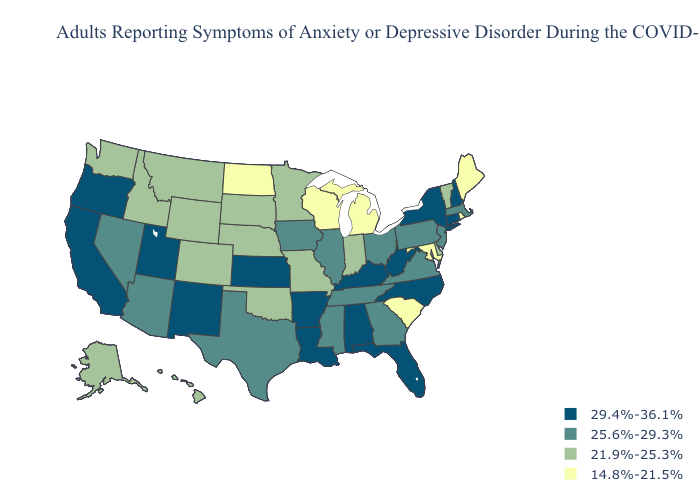What is the value of Indiana?
Answer briefly. 21.9%-25.3%. Name the states that have a value in the range 25.6%-29.3%?
Quick response, please. Arizona, Georgia, Illinois, Iowa, Massachusetts, Mississippi, Nevada, New Jersey, Ohio, Pennsylvania, Tennessee, Texas, Virginia. Name the states that have a value in the range 25.6%-29.3%?
Give a very brief answer. Arizona, Georgia, Illinois, Iowa, Massachusetts, Mississippi, Nevada, New Jersey, Ohio, Pennsylvania, Tennessee, Texas, Virginia. Name the states that have a value in the range 25.6%-29.3%?
Quick response, please. Arizona, Georgia, Illinois, Iowa, Massachusetts, Mississippi, Nevada, New Jersey, Ohio, Pennsylvania, Tennessee, Texas, Virginia. Which states have the lowest value in the West?
Write a very short answer. Alaska, Colorado, Hawaii, Idaho, Montana, Washington, Wyoming. How many symbols are there in the legend?
Concise answer only. 4. Among the states that border Colorado , which have the lowest value?
Keep it brief. Nebraska, Oklahoma, Wyoming. Among the states that border Montana , does North Dakota have the lowest value?
Concise answer only. Yes. Does Missouri have the same value as South Dakota?
Write a very short answer. Yes. Does Connecticut have the highest value in the USA?
Short answer required. Yes. What is the value of Kentucky?
Be succinct. 29.4%-36.1%. Does South Dakota have a lower value than California?
Write a very short answer. Yes. What is the highest value in states that border New Jersey?
Quick response, please. 29.4%-36.1%. What is the value of Kentucky?
Answer briefly. 29.4%-36.1%. What is the value of Delaware?
Keep it brief. 21.9%-25.3%. 